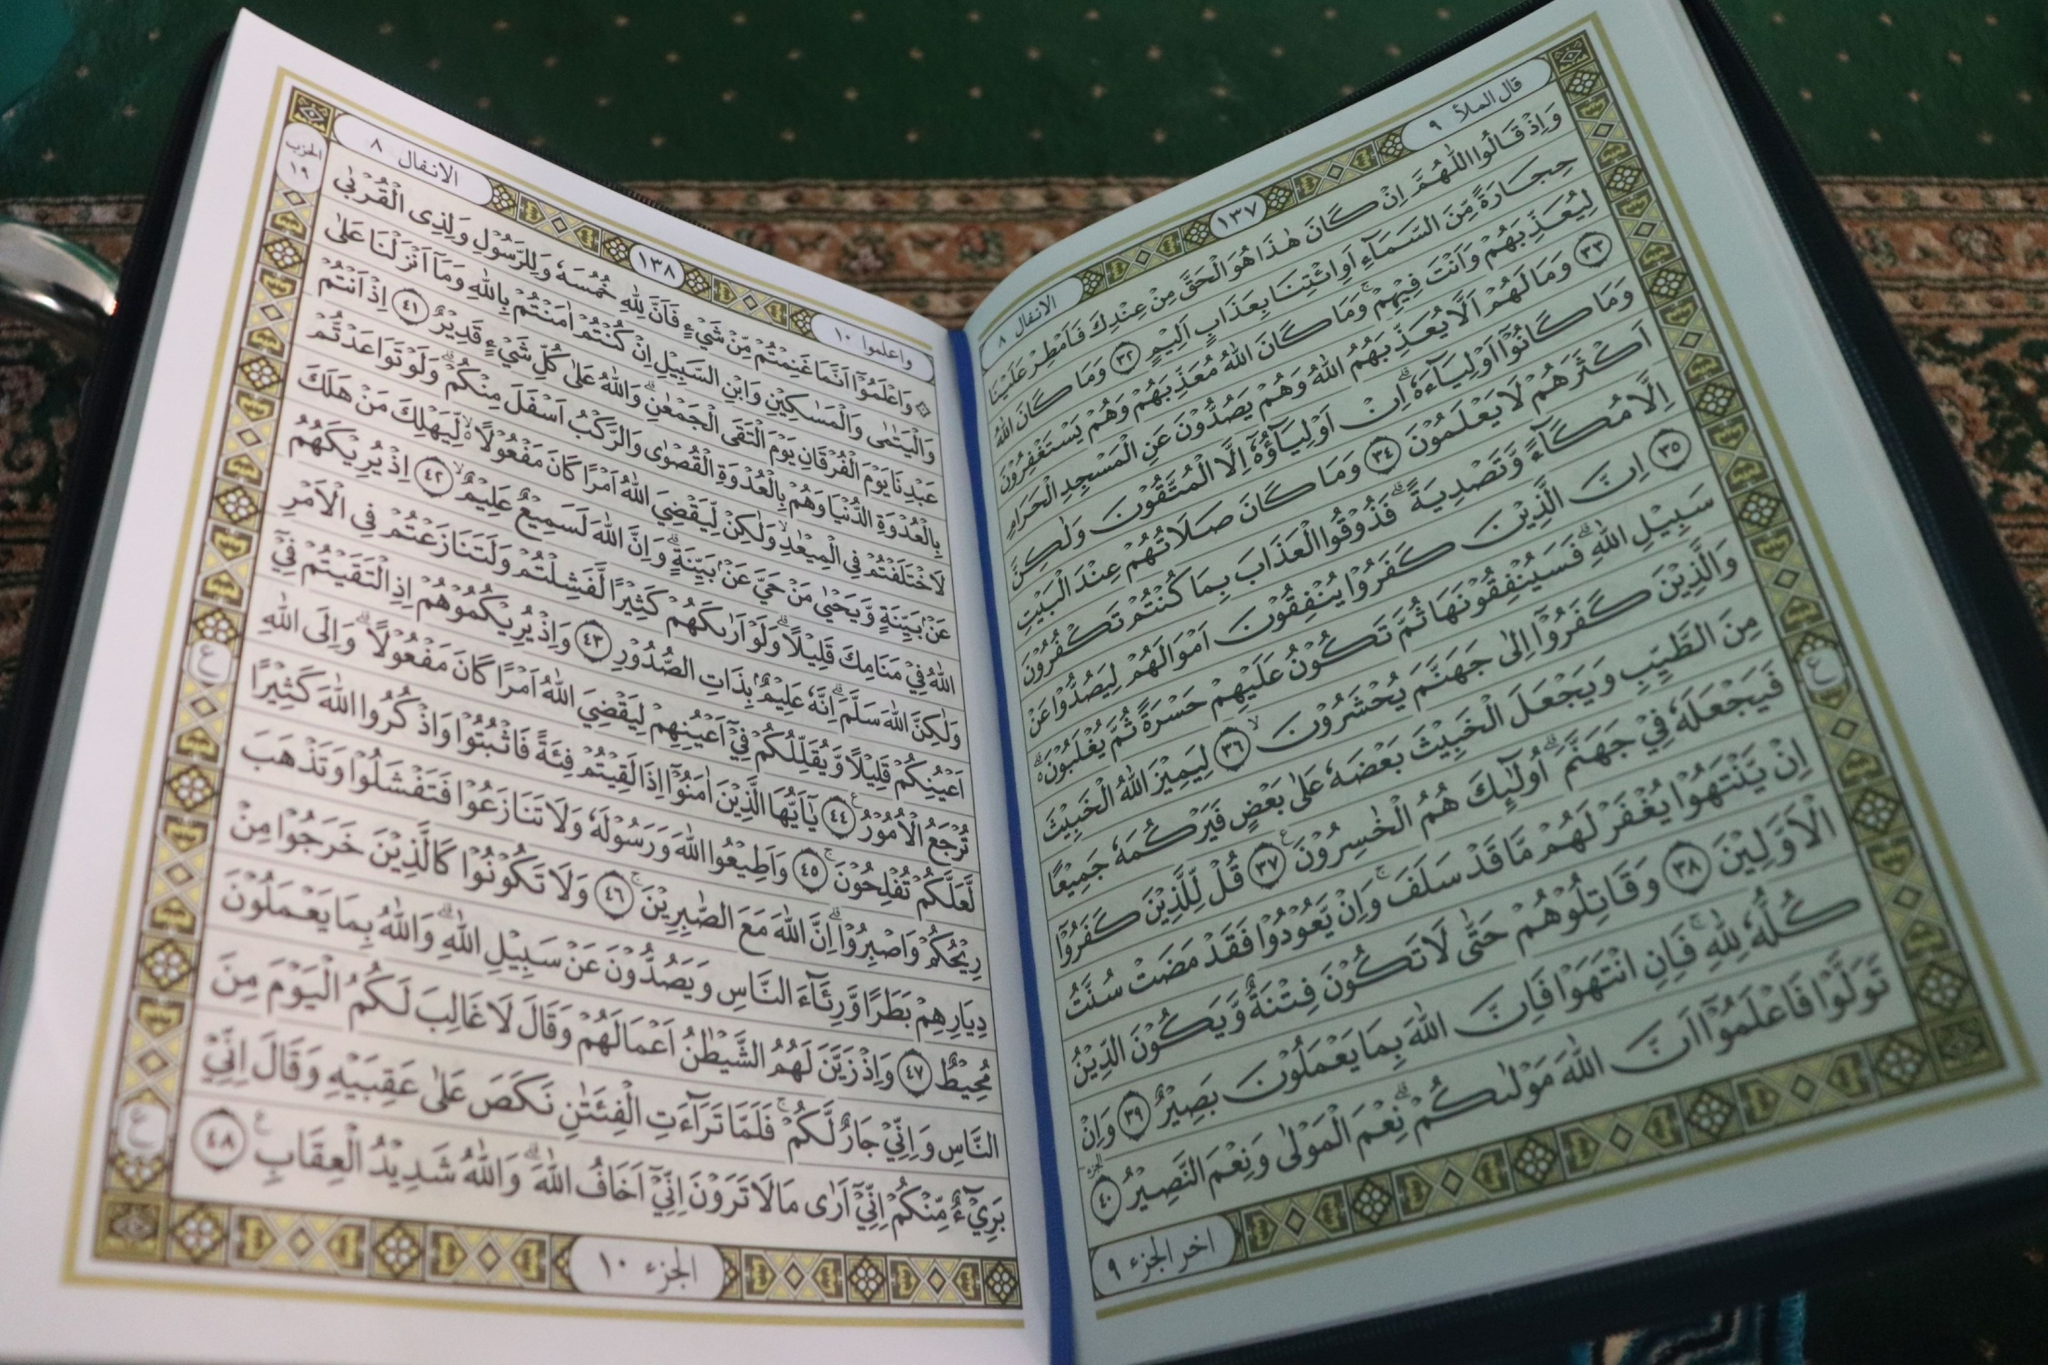Describe the artistic elements on the pages and their possible significance. The artistic elements on the pages include ornate calligraphy, geometric patterns, and decorative borders. The calligraphy is not just a functional medium for the text but an art form intended to beautify the sacred words, reflecting their divine origin. Geometric patterns, composed of interlocking shapes and designs, symbolize infinity and the vastness of the cosmos, suggesting the eternal nature of the divine message. Decorative borders, often adorned with floral and abstract motifs, might symbolize paradise, echoing the themes of beauty, peace, and divine order present within the text. 